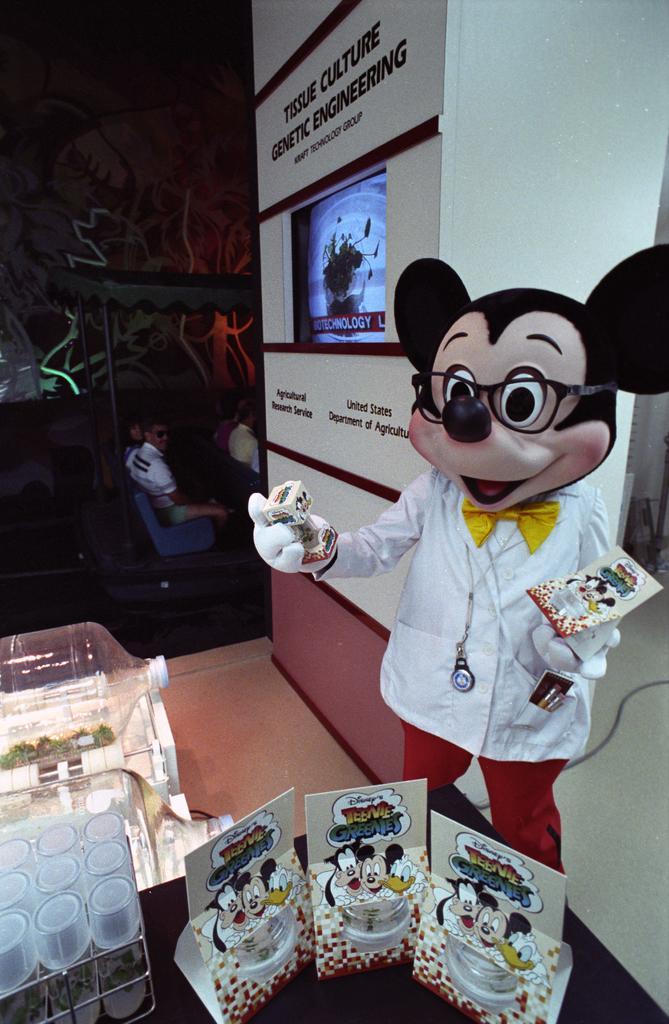Could you give a brief overview of what you see in this image? On the right side of the image we can see mickey mouse toy. On the left side of the image we can see persons, glasses, water tin. In the background we can see wall and television. 